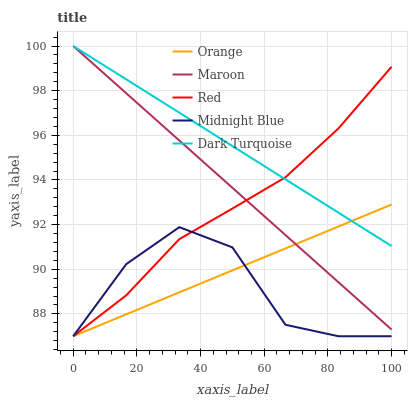Does Midnight Blue have the minimum area under the curve?
Answer yes or no. Yes. Does Dark Turquoise have the maximum area under the curve?
Answer yes or no. Yes. Does Red have the minimum area under the curve?
Answer yes or no. No. Does Red have the maximum area under the curve?
Answer yes or no. No. Is Maroon the smoothest?
Answer yes or no. Yes. Is Midnight Blue the roughest?
Answer yes or no. Yes. Is Dark Turquoise the smoothest?
Answer yes or no. No. Is Dark Turquoise the roughest?
Answer yes or no. No. Does Orange have the lowest value?
Answer yes or no. Yes. Does Dark Turquoise have the lowest value?
Answer yes or no. No. Does Maroon have the highest value?
Answer yes or no. Yes. Does Red have the highest value?
Answer yes or no. No. Is Midnight Blue less than Dark Turquoise?
Answer yes or no. Yes. Is Maroon greater than Midnight Blue?
Answer yes or no. Yes. Does Red intersect Maroon?
Answer yes or no. Yes. Is Red less than Maroon?
Answer yes or no. No. Is Red greater than Maroon?
Answer yes or no. No. Does Midnight Blue intersect Dark Turquoise?
Answer yes or no. No. 